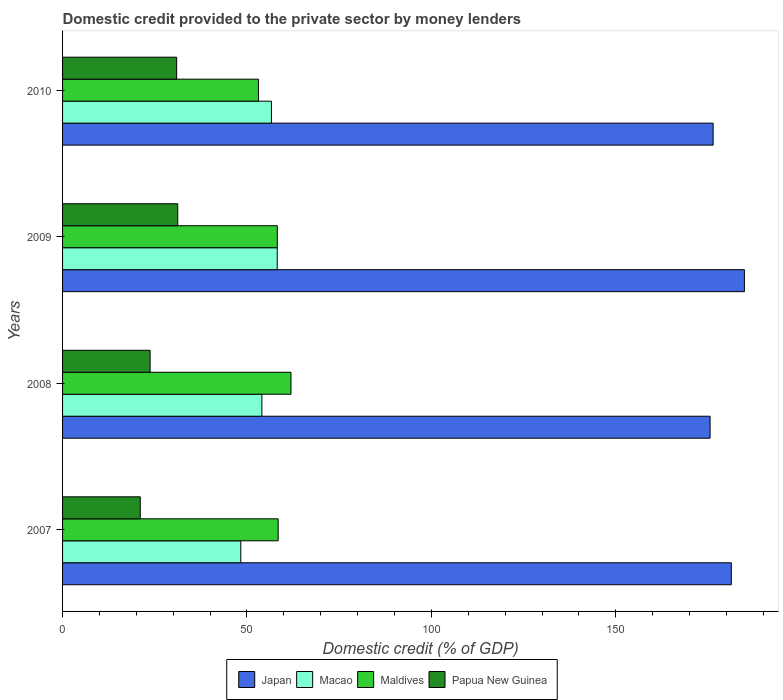How many groups of bars are there?
Offer a very short reply. 4. Are the number of bars on each tick of the Y-axis equal?
Your answer should be very brief. Yes. How many bars are there on the 4th tick from the bottom?
Your answer should be compact. 4. In how many cases, is the number of bars for a given year not equal to the number of legend labels?
Ensure brevity in your answer.  0. What is the domestic credit provided to the private sector by money lenders in Macao in 2007?
Offer a very short reply. 48.32. Across all years, what is the maximum domestic credit provided to the private sector by money lenders in Papua New Guinea?
Your answer should be very brief. 31.23. Across all years, what is the minimum domestic credit provided to the private sector by money lenders in Japan?
Offer a terse response. 175.57. What is the total domestic credit provided to the private sector by money lenders in Japan in the graph?
Provide a short and direct response. 718.17. What is the difference between the domestic credit provided to the private sector by money lenders in Macao in 2008 and that in 2010?
Ensure brevity in your answer.  -2.59. What is the difference between the domestic credit provided to the private sector by money lenders in Papua New Guinea in 2010 and the domestic credit provided to the private sector by money lenders in Japan in 2007?
Provide a short and direct response. -150.39. What is the average domestic credit provided to the private sector by money lenders in Japan per year?
Your answer should be very brief. 179.54. In the year 2007, what is the difference between the domestic credit provided to the private sector by money lenders in Macao and domestic credit provided to the private sector by money lenders in Maldives?
Keep it short and to the point. -10.14. What is the ratio of the domestic credit provided to the private sector by money lenders in Macao in 2007 to that in 2008?
Your answer should be compact. 0.89. What is the difference between the highest and the second highest domestic credit provided to the private sector by money lenders in Japan?
Make the answer very short. 3.55. What is the difference between the highest and the lowest domestic credit provided to the private sector by money lenders in Papua New Guinea?
Offer a very short reply. 10.17. Is the sum of the domestic credit provided to the private sector by money lenders in Macao in 2009 and 2010 greater than the maximum domestic credit provided to the private sector by money lenders in Maldives across all years?
Your response must be concise. Yes. Is it the case that in every year, the sum of the domestic credit provided to the private sector by money lenders in Japan and domestic credit provided to the private sector by money lenders in Macao is greater than the sum of domestic credit provided to the private sector by money lenders in Maldives and domestic credit provided to the private sector by money lenders in Papua New Guinea?
Provide a succinct answer. Yes. What does the 2nd bar from the top in 2007 represents?
Give a very brief answer. Maldives. What does the 3rd bar from the bottom in 2007 represents?
Provide a succinct answer. Maldives. How many bars are there?
Provide a short and direct response. 16. How many years are there in the graph?
Make the answer very short. 4. Are the values on the major ticks of X-axis written in scientific E-notation?
Ensure brevity in your answer.  No. Does the graph contain any zero values?
Give a very brief answer. No. Does the graph contain grids?
Your answer should be compact. No. Where does the legend appear in the graph?
Make the answer very short. Bottom center. How many legend labels are there?
Provide a short and direct response. 4. What is the title of the graph?
Offer a terse response. Domestic credit provided to the private sector by money lenders. Does "Benin" appear as one of the legend labels in the graph?
Provide a short and direct response. No. What is the label or title of the X-axis?
Make the answer very short. Domestic credit (% of GDP). What is the Domestic credit (% of GDP) of Japan in 2007?
Provide a succinct answer. 181.33. What is the Domestic credit (% of GDP) of Macao in 2007?
Offer a very short reply. 48.32. What is the Domestic credit (% of GDP) in Maldives in 2007?
Ensure brevity in your answer.  58.46. What is the Domestic credit (% of GDP) in Papua New Guinea in 2007?
Your answer should be very brief. 21.07. What is the Domestic credit (% of GDP) in Japan in 2008?
Your answer should be very brief. 175.57. What is the Domestic credit (% of GDP) of Macao in 2008?
Give a very brief answer. 54.04. What is the Domestic credit (% of GDP) in Maldives in 2008?
Provide a short and direct response. 61.93. What is the Domestic credit (% of GDP) of Papua New Guinea in 2008?
Provide a succinct answer. 23.74. What is the Domestic credit (% of GDP) of Japan in 2009?
Ensure brevity in your answer.  184.87. What is the Domestic credit (% of GDP) of Macao in 2009?
Your answer should be compact. 58.2. What is the Domestic credit (% of GDP) of Maldives in 2009?
Your answer should be very brief. 58.22. What is the Domestic credit (% of GDP) in Papua New Guinea in 2009?
Provide a succinct answer. 31.23. What is the Domestic credit (% of GDP) of Japan in 2010?
Your answer should be compact. 176.4. What is the Domestic credit (% of GDP) in Macao in 2010?
Offer a very short reply. 56.63. What is the Domestic credit (% of GDP) of Maldives in 2010?
Provide a succinct answer. 53.12. What is the Domestic credit (% of GDP) in Papua New Guinea in 2010?
Keep it short and to the point. 30.94. Across all years, what is the maximum Domestic credit (% of GDP) of Japan?
Provide a succinct answer. 184.87. Across all years, what is the maximum Domestic credit (% of GDP) in Macao?
Your answer should be very brief. 58.2. Across all years, what is the maximum Domestic credit (% of GDP) in Maldives?
Ensure brevity in your answer.  61.93. Across all years, what is the maximum Domestic credit (% of GDP) in Papua New Guinea?
Ensure brevity in your answer.  31.23. Across all years, what is the minimum Domestic credit (% of GDP) of Japan?
Offer a terse response. 175.57. Across all years, what is the minimum Domestic credit (% of GDP) of Macao?
Provide a succinct answer. 48.32. Across all years, what is the minimum Domestic credit (% of GDP) in Maldives?
Keep it short and to the point. 53.12. Across all years, what is the minimum Domestic credit (% of GDP) in Papua New Guinea?
Provide a short and direct response. 21.07. What is the total Domestic credit (% of GDP) in Japan in the graph?
Provide a succinct answer. 718.17. What is the total Domestic credit (% of GDP) of Macao in the graph?
Provide a short and direct response. 217.2. What is the total Domestic credit (% of GDP) of Maldives in the graph?
Offer a terse response. 231.73. What is the total Domestic credit (% of GDP) in Papua New Guinea in the graph?
Offer a terse response. 106.98. What is the difference between the Domestic credit (% of GDP) of Japan in 2007 and that in 2008?
Your answer should be very brief. 5.76. What is the difference between the Domestic credit (% of GDP) of Macao in 2007 and that in 2008?
Offer a very short reply. -5.72. What is the difference between the Domestic credit (% of GDP) in Maldives in 2007 and that in 2008?
Make the answer very short. -3.47. What is the difference between the Domestic credit (% of GDP) in Papua New Guinea in 2007 and that in 2008?
Ensure brevity in your answer.  -2.67. What is the difference between the Domestic credit (% of GDP) of Japan in 2007 and that in 2009?
Provide a short and direct response. -3.55. What is the difference between the Domestic credit (% of GDP) in Macao in 2007 and that in 2009?
Offer a very short reply. -9.88. What is the difference between the Domestic credit (% of GDP) of Maldives in 2007 and that in 2009?
Keep it short and to the point. 0.24. What is the difference between the Domestic credit (% of GDP) of Papua New Guinea in 2007 and that in 2009?
Your answer should be compact. -10.17. What is the difference between the Domestic credit (% of GDP) in Japan in 2007 and that in 2010?
Offer a very short reply. 4.93. What is the difference between the Domestic credit (% of GDP) in Macao in 2007 and that in 2010?
Offer a very short reply. -8.31. What is the difference between the Domestic credit (% of GDP) in Maldives in 2007 and that in 2010?
Provide a short and direct response. 5.34. What is the difference between the Domestic credit (% of GDP) of Papua New Guinea in 2007 and that in 2010?
Your answer should be compact. -9.87. What is the difference between the Domestic credit (% of GDP) in Japan in 2008 and that in 2009?
Your response must be concise. -9.3. What is the difference between the Domestic credit (% of GDP) in Macao in 2008 and that in 2009?
Make the answer very short. -4.16. What is the difference between the Domestic credit (% of GDP) in Maldives in 2008 and that in 2009?
Your answer should be compact. 3.71. What is the difference between the Domestic credit (% of GDP) of Papua New Guinea in 2008 and that in 2009?
Give a very brief answer. -7.49. What is the difference between the Domestic credit (% of GDP) of Japan in 2008 and that in 2010?
Your answer should be compact. -0.83. What is the difference between the Domestic credit (% of GDP) in Macao in 2008 and that in 2010?
Give a very brief answer. -2.59. What is the difference between the Domestic credit (% of GDP) in Maldives in 2008 and that in 2010?
Keep it short and to the point. 8.81. What is the difference between the Domestic credit (% of GDP) of Papua New Guinea in 2008 and that in 2010?
Provide a short and direct response. -7.19. What is the difference between the Domestic credit (% of GDP) in Japan in 2009 and that in 2010?
Offer a very short reply. 8.48. What is the difference between the Domestic credit (% of GDP) of Macao in 2009 and that in 2010?
Give a very brief answer. 1.57. What is the difference between the Domestic credit (% of GDP) of Maldives in 2009 and that in 2010?
Give a very brief answer. 5.11. What is the difference between the Domestic credit (% of GDP) in Papua New Guinea in 2009 and that in 2010?
Provide a short and direct response. 0.3. What is the difference between the Domestic credit (% of GDP) of Japan in 2007 and the Domestic credit (% of GDP) of Macao in 2008?
Provide a short and direct response. 127.29. What is the difference between the Domestic credit (% of GDP) in Japan in 2007 and the Domestic credit (% of GDP) in Maldives in 2008?
Provide a short and direct response. 119.4. What is the difference between the Domestic credit (% of GDP) in Japan in 2007 and the Domestic credit (% of GDP) in Papua New Guinea in 2008?
Your response must be concise. 157.59. What is the difference between the Domestic credit (% of GDP) in Macao in 2007 and the Domestic credit (% of GDP) in Maldives in 2008?
Your answer should be very brief. -13.61. What is the difference between the Domestic credit (% of GDP) in Macao in 2007 and the Domestic credit (% of GDP) in Papua New Guinea in 2008?
Provide a succinct answer. 24.58. What is the difference between the Domestic credit (% of GDP) in Maldives in 2007 and the Domestic credit (% of GDP) in Papua New Guinea in 2008?
Your answer should be very brief. 34.72. What is the difference between the Domestic credit (% of GDP) in Japan in 2007 and the Domestic credit (% of GDP) in Macao in 2009?
Your response must be concise. 123.13. What is the difference between the Domestic credit (% of GDP) in Japan in 2007 and the Domestic credit (% of GDP) in Maldives in 2009?
Provide a short and direct response. 123.11. What is the difference between the Domestic credit (% of GDP) in Japan in 2007 and the Domestic credit (% of GDP) in Papua New Guinea in 2009?
Offer a very short reply. 150.1. What is the difference between the Domestic credit (% of GDP) in Macao in 2007 and the Domestic credit (% of GDP) in Maldives in 2009?
Your answer should be compact. -9.9. What is the difference between the Domestic credit (% of GDP) in Macao in 2007 and the Domestic credit (% of GDP) in Papua New Guinea in 2009?
Your answer should be very brief. 17.09. What is the difference between the Domestic credit (% of GDP) in Maldives in 2007 and the Domestic credit (% of GDP) in Papua New Guinea in 2009?
Provide a succinct answer. 27.23. What is the difference between the Domestic credit (% of GDP) of Japan in 2007 and the Domestic credit (% of GDP) of Macao in 2010?
Keep it short and to the point. 124.7. What is the difference between the Domestic credit (% of GDP) of Japan in 2007 and the Domestic credit (% of GDP) of Maldives in 2010?
Your response must be concise. 128.21. What is the difference between the Domestic credit (% of GDP) of Japan in 2007 and the Domestic credit (% of GDP) of Papua New Guinea in 2010?
Offer a very short reply. 150.39. What is the difference between the Domestic credit (% of GDP) of Macao in 2007 and the Domestic credit (% of GDP) of Maldives in 2010?
Ensure brevity in your answer.  -4.8. What is the difference between the Domestic credit (% of GDP) in Macao in 2007 and the Domestic credit (% of GDP) in Papua New Guinea in 2010?
Give a very brief answer. 17.39. What is the difference between the Domestic credit (% of GDP) in Maldives in 2007 and the Domestic credit (% of GDP) in Papua New Guinea in 2010?
Give a very brief answer. 27.52. What is the difference between the Domestic credit (% of GDP) of Japan in 2008 and the Domestic credit (% of GDP) of Macao in 2009?
Ensure brevity in your answer.  117.37. What is the difference between the Domestic credit (% of GDP) in Japan in 2008 and the Domestic credit (% of GDP) in Maldives in 2009?
Offer a terse response. 117.35. What is the difference between the Domestic credit (% of GDP) of Japan in 2008 and the Domestic credit (% of GDP) of Papua New Guinea in 2009?
Offer a terse response. 144.34. What is the difference between the Domestic credit (% of GDP) in Macao in 2008 and the Domestic credit (% of GDP) in Maldives in 2009?
Ensure brevity in your answer.  -4.18. What is the difference between the Domestic credit (% of GDP) in Macao in 2008 and the Domestic credit (% of GDP) in Papua New Guinea in 2009?
Offer a terse response. 22.81. What is the difference between the Domestic credit (% of GDP) in Maldives in 2008 and the Domestic credit (% of GDP) in Papua New Guinea in 2009?
Your answer should be compact. 30.7. What is the difference between the Domestic credit (% of GDP) in Japan in 2008 and the Domestic credit (% of GDP) in Macao in 2010?
Your answer should be very brief. 118.94. What is the difference between the Domestic credit (% of GDP) in Japan in 2008 and the Domestic credit (% of GDP) in Maldives in 2010?
Provide a short and direct response. 122.45. What is the difference between the Domestic credit (% of GDP) in Japan in 2008 and the Domestic credit (% of GDP) in Papua New Guinea in 2010?
Make the answer very short. 144.64. What is the difference between the Domestic credit (% of GDP) of Macao in 2008 and the Domestic credit (% of GDP) of Maldives in 2010?
Offer a terse response. 0.92. What is the difference between the Domestic credit (% of GDP) of Macao in 2008 and the Domestic credit (% of GDP) of Papua New Guinea in 2010?
Your response must be concise. 23.11. What is the difference between the Domestic credit (% of GDP) of Maldives in 2008 and the Domestic credit (% of GDP) of Papua New Guinea in 2010?
Provide a succinct answer. 30.99. What is the difference between the Domestic credit (% of GDP) in Japan in 2009 and the Domestic credit (% of GDP) in Macao in 2010?
Offer a terse response. 128.24. What is the difference between the Domestic credit (% of GDP) in Japan in 2009 and the Domestic credit (% of GDP) in Maldives in 2010?
Offer a very short reply. 131.76. What is the difference between the Domestic credit (% of GDP) of Japan in 2009 and the Domestic credit (% of GDP) of Papua New Guinea in 2010?
Your answer should be very brief. 153.94. What is the difference between the Domestic credit (% of GDP) in Macao in 2009 and the Domestic credit (% of GDP) in Maldives in 2010?
Ensure brevity in your answer.  5.08. What is the difference between the Domestic credit (% of GDP) in Macao in 2009 and the Domestic credit (% of GDP) in Papua New Guinea in 2010?
Provide a short and direct response. 27.27. What is the difference between the Domestic credit (% of GDP) of Maldives in 2009 and the Domestic credit (% of GDP) of Papua New Guinea in 2010?
Ensure brevity in your answer.  27.29. What is the average Domestic credit (% of GDP) of Japan per year?
Your response must be concise. 179.54. What is the average Domestic credit (% of GDP) in Macao per year?
Provide a succinct answer. 54.3. What is the average Domestic credit (% of GDP) of Maldives per year?
Your answer should be compact. 57.93. What is the average Domestic credit (% of GDP) of Papua New Guinea per year?
Ensure brevity in your answer.  26.74. In the year 2007, what is the difference between the Domestic credit (% of GDP) of Japan and Domestic credit (% of GDP) of Macao?
Ensure brevity in your answer.  133.01. In the year 2007, what is the difference between the Domestic credit (% of GDP) in Japan and Domestic credit (% of GDP) in Maldives?
Make the answer very short. 122.87. In the year 2007, what is the difference between the Domestic credit (% of GDP) of Japan and Domestic credit (% of GDP) of Papua New Guinea?
Your answer should be compact. 160.26. In the year 2007, what is the difference between the Domestic credit (% of GDP) of Macao and Domestic credit (% of GDP) of Maldives?
Provide a short and direct response. -10.14. In the year 2007, what is the difference between the Domestic credit (% of GDP) in Macao and Domestic credit (% of GDP) in Papua New Guinea?
Make the answer very short. 27.25. In the year 2007, what is the difference between the Domestic credit (% of GDP) in Maldives and Domestic credit (% of GDP) in Papua New Guinea?
Your response must be concise. 37.39. In the year 2008, what is the difference between the Domestic credit (% of GDP) of Japan and Domestic credit (% of GDP) of Macao?
Provide a succinct answer. 121.53. In the year 2008, what is the difference between the Domestic credit (% of GDP) of Japan and Domestic credit (% of GDP) of Maldives?
Provide a short and direct response. 113.64. In the year 2008, what is the difference between the Domestic credit (% of GDP) in Japan and Domestic credit (% of GDP) in Papua New Guinea?
Offer a very short reply. 151.83. In the year 2008, what is the difference between the Domestic credit (% of GDP) of Macao and Domestic credit (% of GDP) of Maldives?
Your answer should be very brief. -7.89. In the year 2008, what is the difference between the Domestic credit (% of GDP) of Macao and Domestic credit (% of GDP) of Papua New Guinea?
Offer a very short reply. 30.3. In the year 2008, what is the difference between the Domestic credit (% of GDP) in Maldives and Domestic credit (% of GDP) in Papua New Guinea?
Keep it short and to the point. 38.19. In the year 2009, what is the difference between the Domestic credit (% of GDP) in Japan and Domestic credit (% of GDP) in Macao?
Your answer should be very brief. 126.67. In the year 2009, what is the difference between the Domestic credit (% of GDP) of Japan and Domestic credit (% of GDP) of Maldives?
Provide a short and direct response. 126.65. In the year 2009, what is the difference between the Domestic credit (% of GDP) of Japan and Domestic credit (% of GDP) of Papua New Guinea?
Your answer should be compact. 153.64. In the year 2009, what is the difference between the Domestic credit (% of GDP) in Macao and Domestic credit (% of GDP) in Maldives?
Your answer should be very brief. -0.02. In the year 2009, what is the difference between the Domestic credit (% of GDP) of Macao and Domestic credit (% of GDP) of Papua New Guinea?
Give a very brief answer. 26.97. In the year 2009, what is the difference between the Domestic credit (% of GDP) in Maldives and Domestic credit (% of GDP) in Papua New Guinea?
Your response must be concise. 26.99. In the year 2010, what is the difference between the Domestic credit (% of GDP) of Japan and Domestic credit (% of GDP) of Macao?
Your response must be concise. 119.76. In the year 2010, what is the difference between the Domestic credit (% of GDP) of Japan and Domestic credit (% of GDP) of Maldives?
Give a very brief answer. 123.28. In the year 2010, what is the difference between the Domestic credit (% of GDP) in Japan and Domestic credit (% of GDP) in Papua New Guinea?
Keep it short and to the point. 145.46. In the year 2010, what is the difference between the Domestic credit (% of GDP) of Macao and Domestic credit (% of GDP) of Maldives?
Your answer should be very brief. 3.52. In the year 2010, what is the difference between the Domestic credit (% of GDP) of Macao and Domestic credit (% of GDP) of Papua New Guinea?
Your answer should be compact. 25.7. In the year 2010, what is the difference between the Domestic credit (% of GDP) of Maldives and Domestic credit (% of GDP) of Papua New Guinea?
Provide a short and direct response. 22.18. What is the ratio of the Domestic credit (% of GDP) in Japan in 2007 to that in 2008?
Your answer should be very brief. 1.03. What is the ratio of the Domestic credit (% of GDP) of Macao in 2007 to that in 2008?
Your answer should be very brief. 0.89. What is the ratio of the Domestic credit (% of GDP) of Maldives in 2007 to that in 2008?
Provide a short and direct response. 0.94. What is the ratio of the Domestic credit (% of GDP) in Papua New Guinea in 2007 to that in 2008?
Offer a terse response. 0.89. What is the ratio of the Domestic credit (% of GDP) of Japan in 2007 to that in 2009?
Offer a terse response. 0.98. What is the ratio of the Domestic credit (% of GDP) of Macao in 2007 to that in 2009?
Keep it short and to the point. 0.83. What is the ratio of the Domestic credit (% of GDP) in Maldives in 2007 to that in 2009?
Provide a succinct answer. 1. What is the ratio of the Domestic credit (% of GDP) in Papua New Guinea in 2007 to that in 2009?
Give a very brief answer. 0.67. What is the ratio of the Domestic credit (% of GDP) in Japan in 2007 to that in 2010?
Keep it short and to the point. 1.03. What is the ratio of the Domestic credit (% of GDP) in Macao in 2007 to that in 2010?
Offer a terse response. 0.85. What is the ratio of the Domestic credit (% of GDP) in Maldives in 2007 to that in 2010?
Ensure brevity in your answer.  1.1. What is the ratio of the Domestic credit (% of GDP) in Papua New Guinea in 2007 to that in 2010?
Keep it short and to the point. 0.68. What is the ratio of the Domestic credit (% of GDP) in Japan in 2008 to that in 2009?
Keep it short and to the point. 0.95. What is the ratio of the Domestic credit (% of GDP) in Macao in 2008 to that in 2009?
Make the answer very short. 0.93. What is the ratio of the Domestic credit (% of GDP) in Maldives in 2008 to that in 2009?
Offer a terse response. 1.06. What is the ratio of the Domestic credit (% of GDP) in Papua New Guinea in 2008 to that in 2009?
Keep it short and to the point. 0.76. What is the ratio of the Domestic credit (% of GDP) of Macao in 2008 to that in 2010?
Your answer should be compact. 0.95. What is the ratio of the Domestic credit (% of GDP) in Maldives in 2008 to that in 2010?
Make the answer very short. 1.17. What is the ratio of the Domestic credit (% of GDP) of Papua New Guinea in 2008 to that in 2010?
Provide a succinct answer. 0.77. What is the ratio of the Domestic credit (% of GDP) in Japan in 2009 to that in 2010?
Offer a very short reply. 1.05. What is the ratio of the Domestic credit (% of GDP) in Macao in 2009 to that in 2010?
Provide a short and direct response. 1.03. What is the ratio of the Domestic credit (% of GDP) in Maldives in 2009 to that in 2010?
Keep it short and to the point. 1.1. What is the ratio of the Domestic credit (% of GDP) of Papua New Guinea in 2009 to that in 2010?
Make the answer very short. 1.01. What is the difference between the highest and the second highest Domestic credit (% of GDP) in Japan?
Offer a very short reply. 3.55. What is the difference between the highest and the second highest Domestic credit (% of GDP) in Macao?
Give a very brief answer. 1.57. What is the difference between the highest and the second highest Domestic credit (% of GDP) in Maldives?
Offer a very short reply. 3.47. What is the difference between the highest and the second highest Domestic credit (% of GDP) in Papua New Guinea?
Provide a short and direct response. 0.3. What is the difference between the highest and the lowest Domestic credit (% of GDP) of Japan?
Provide a short and direct response. 9.3. What is the difference between the highest and the lowest Domestic credit (% of GDP) in Macao?
Provide a succinct answer. 9.88. What is the difference between the highest and the lowest Domestic credit (% of GDP) in Maldives?
Ensure brevity in your answer.  8.81. What is the difference between the highest and the lowest Domestic credit (% of GDP) of Papua New Guinea?
Your answer should be compact. 10.17. 